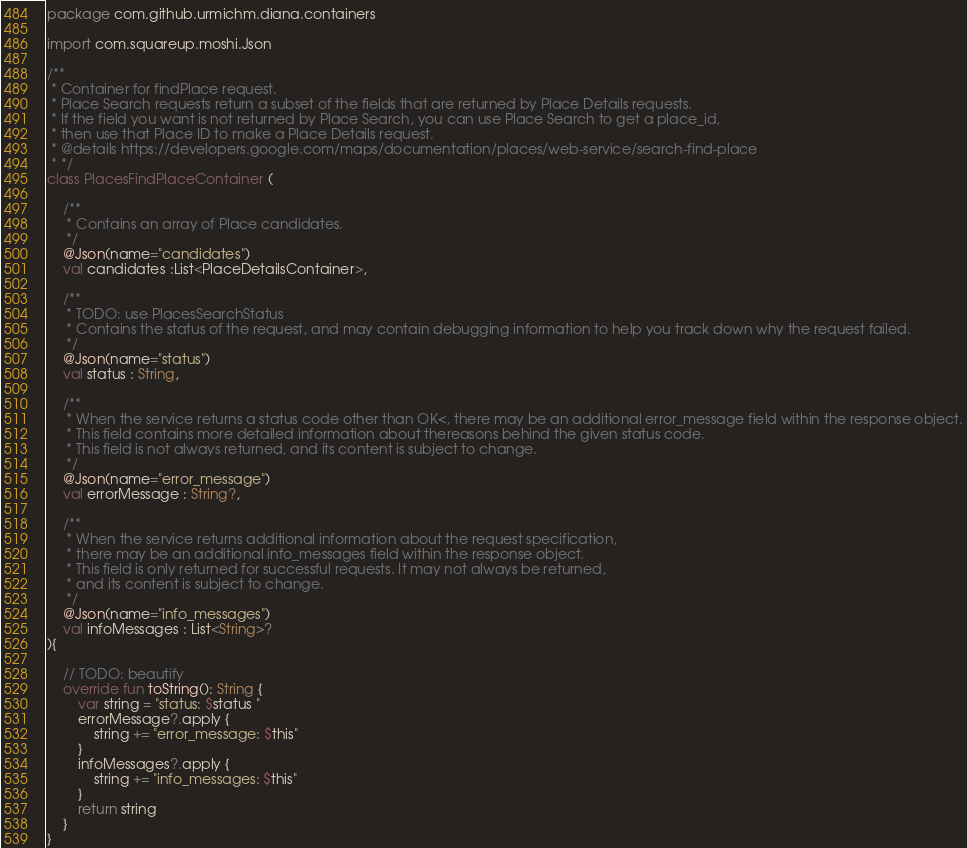<code> <loc_0><loc_0><loc_500><loc_500><_Kotlin_>package com.github.urmichm.diana.containers

import com.squareup.moshi.Json

/**
 * Container for findPlace request.
 * Place Search requests return a subset of the fields that are returned by Place Details requests.
 * If the field you want is not returned by Place Search, you can use Place Search to get a place_id,
 * then use that Place ID to make a Place Details request.
 * @details https://developers.google.com/maps/documentation/places/web-service/search-find-place
 * */
class PlacesFindPlaceContainer (

    /**
     * Contains an array of Place candidates.
     */
    @Json(name="candidates")
    val candidates :List<PlaceDetailsContainer>,

    /**
     * TODO: use PlacesSearchStatus
     * Contains the status of the request, and may contain debugging information to help you track down why the request failed.
     */
    @Json(name="status")
    val status : String,

    /**
     * When the service returns a status code other than OK<, there may be an additional error_message field within the response object.
     * This field contains more detailed information about thereasons behind the given status code.
     * This field is not always returned, and its content is subject to change.
     */
    @Json(name="error_message")
    val errorMessage : String?,

    /**
     * When the service returns additional information about the request specification,
     * there may be an additional info_messages field within the response object.
     * This field is only returned for successful requests. It may not always be returned,
     * and its content is subject to change.
     */
    @Json(name="info_messages")
    val infoMessages : List<String>?
){

    // TODO: beautify
    override fun toString(): String {
        var string = "status: $status "
        errorMessage?.apply {
            string += "error_message: $this"
        }
        infoMessages?.apply {
            string += "info_messages: $this"
        }
        return string
    }
}</code> 